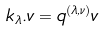<formula> <loc_0><loc_0><loc_500><loc_500>k _ { \lambda } . v = q ^ { ( \lambda , \nu ) } v</formula> 